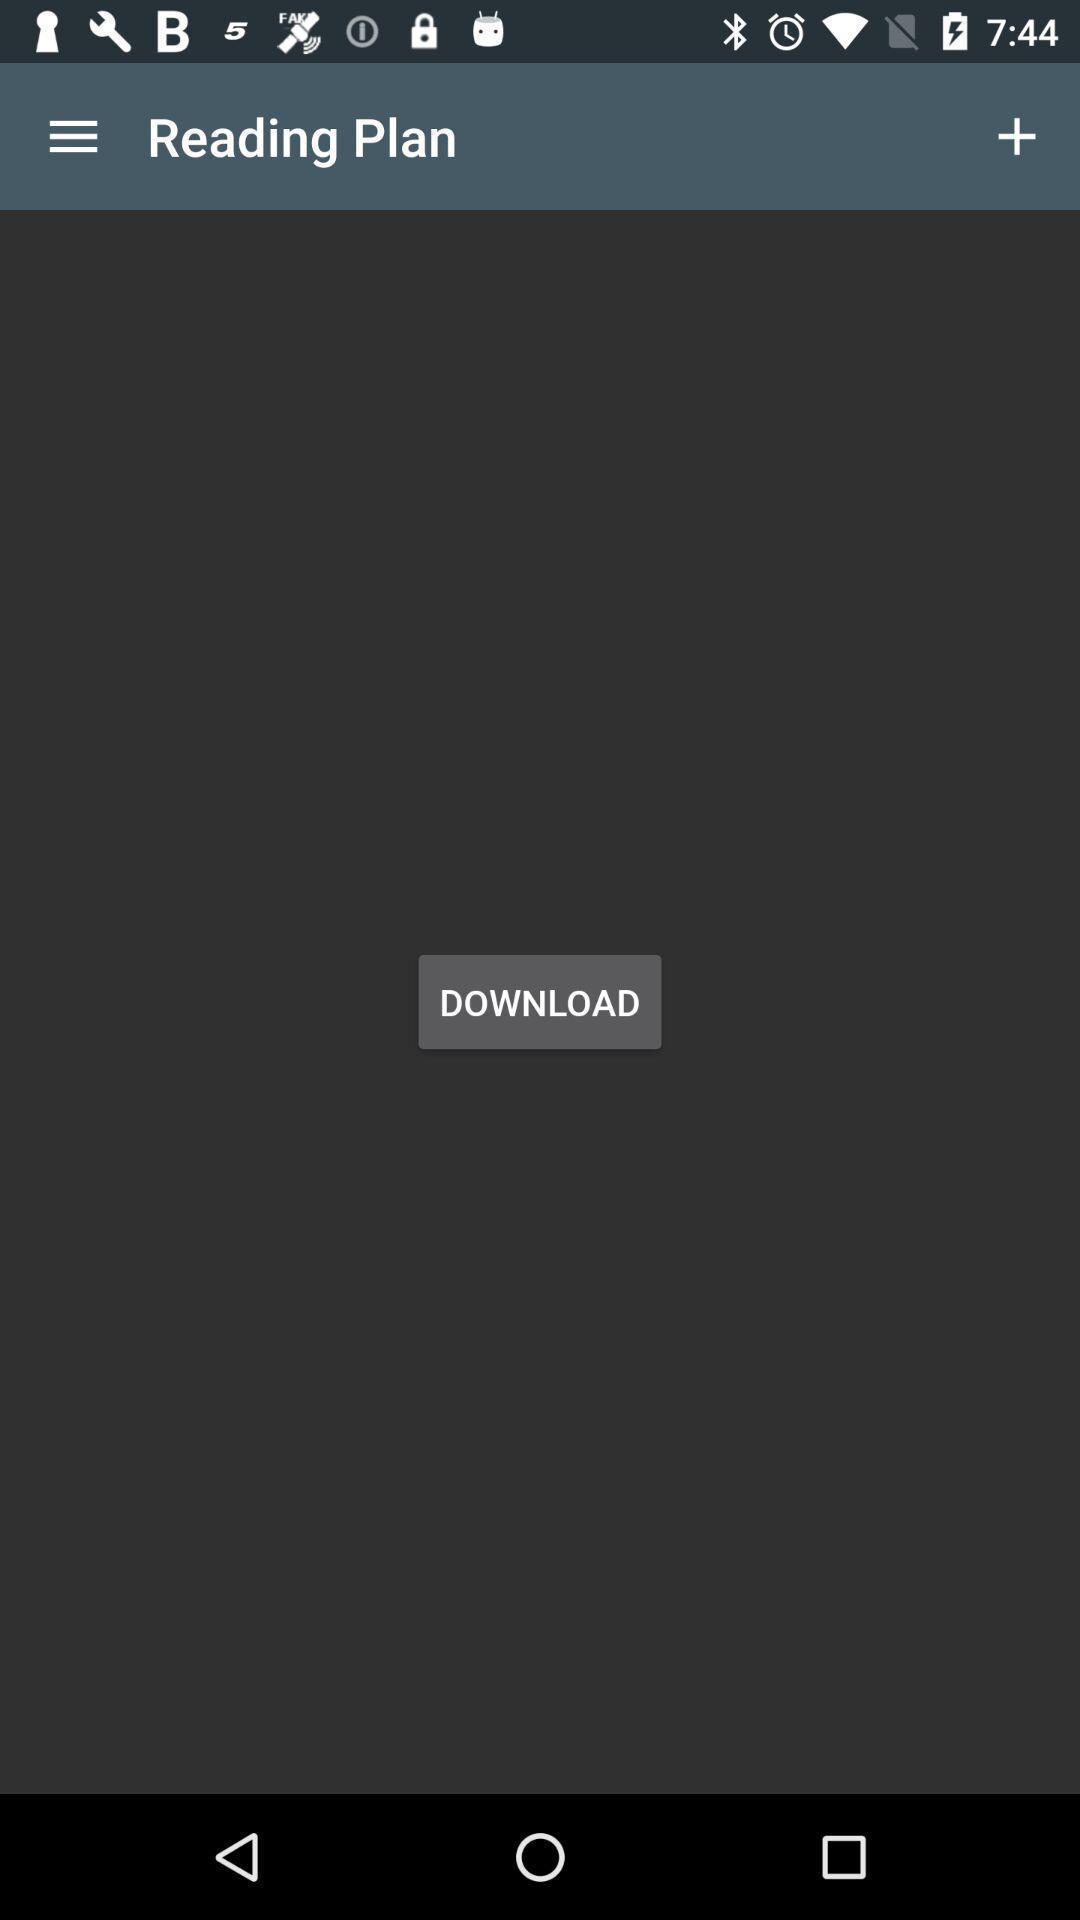Summarize the main components in this picture. Page shows to download your plan. 